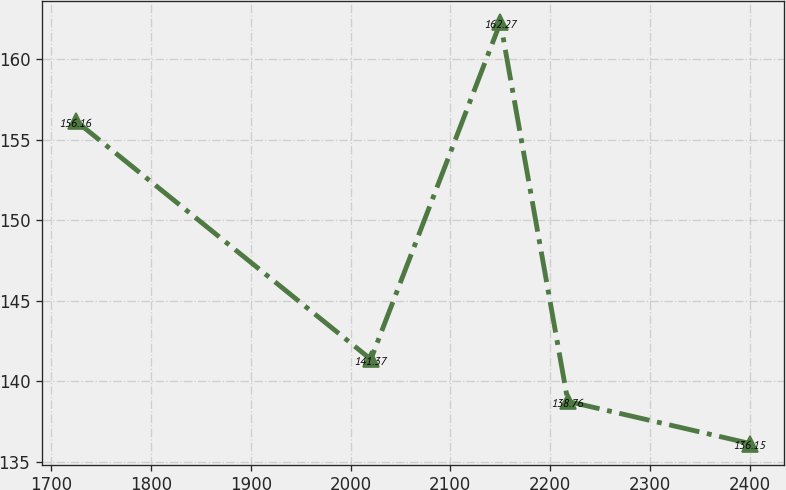<chart> <loc_0><loc_0><loc_500><loc_500><line_chart><ecel><fcel>Unnamed: 1<nl><fcel>1724.64<fcel>156.16<nl><fcel>2020.34<fcel>141.37<nl><fcel>2150.16<fcel>162.27<nl><fcel>2217.72<fcel>138.76<nl><fcel>2400.27<fcel>136.15<nl></chart> 